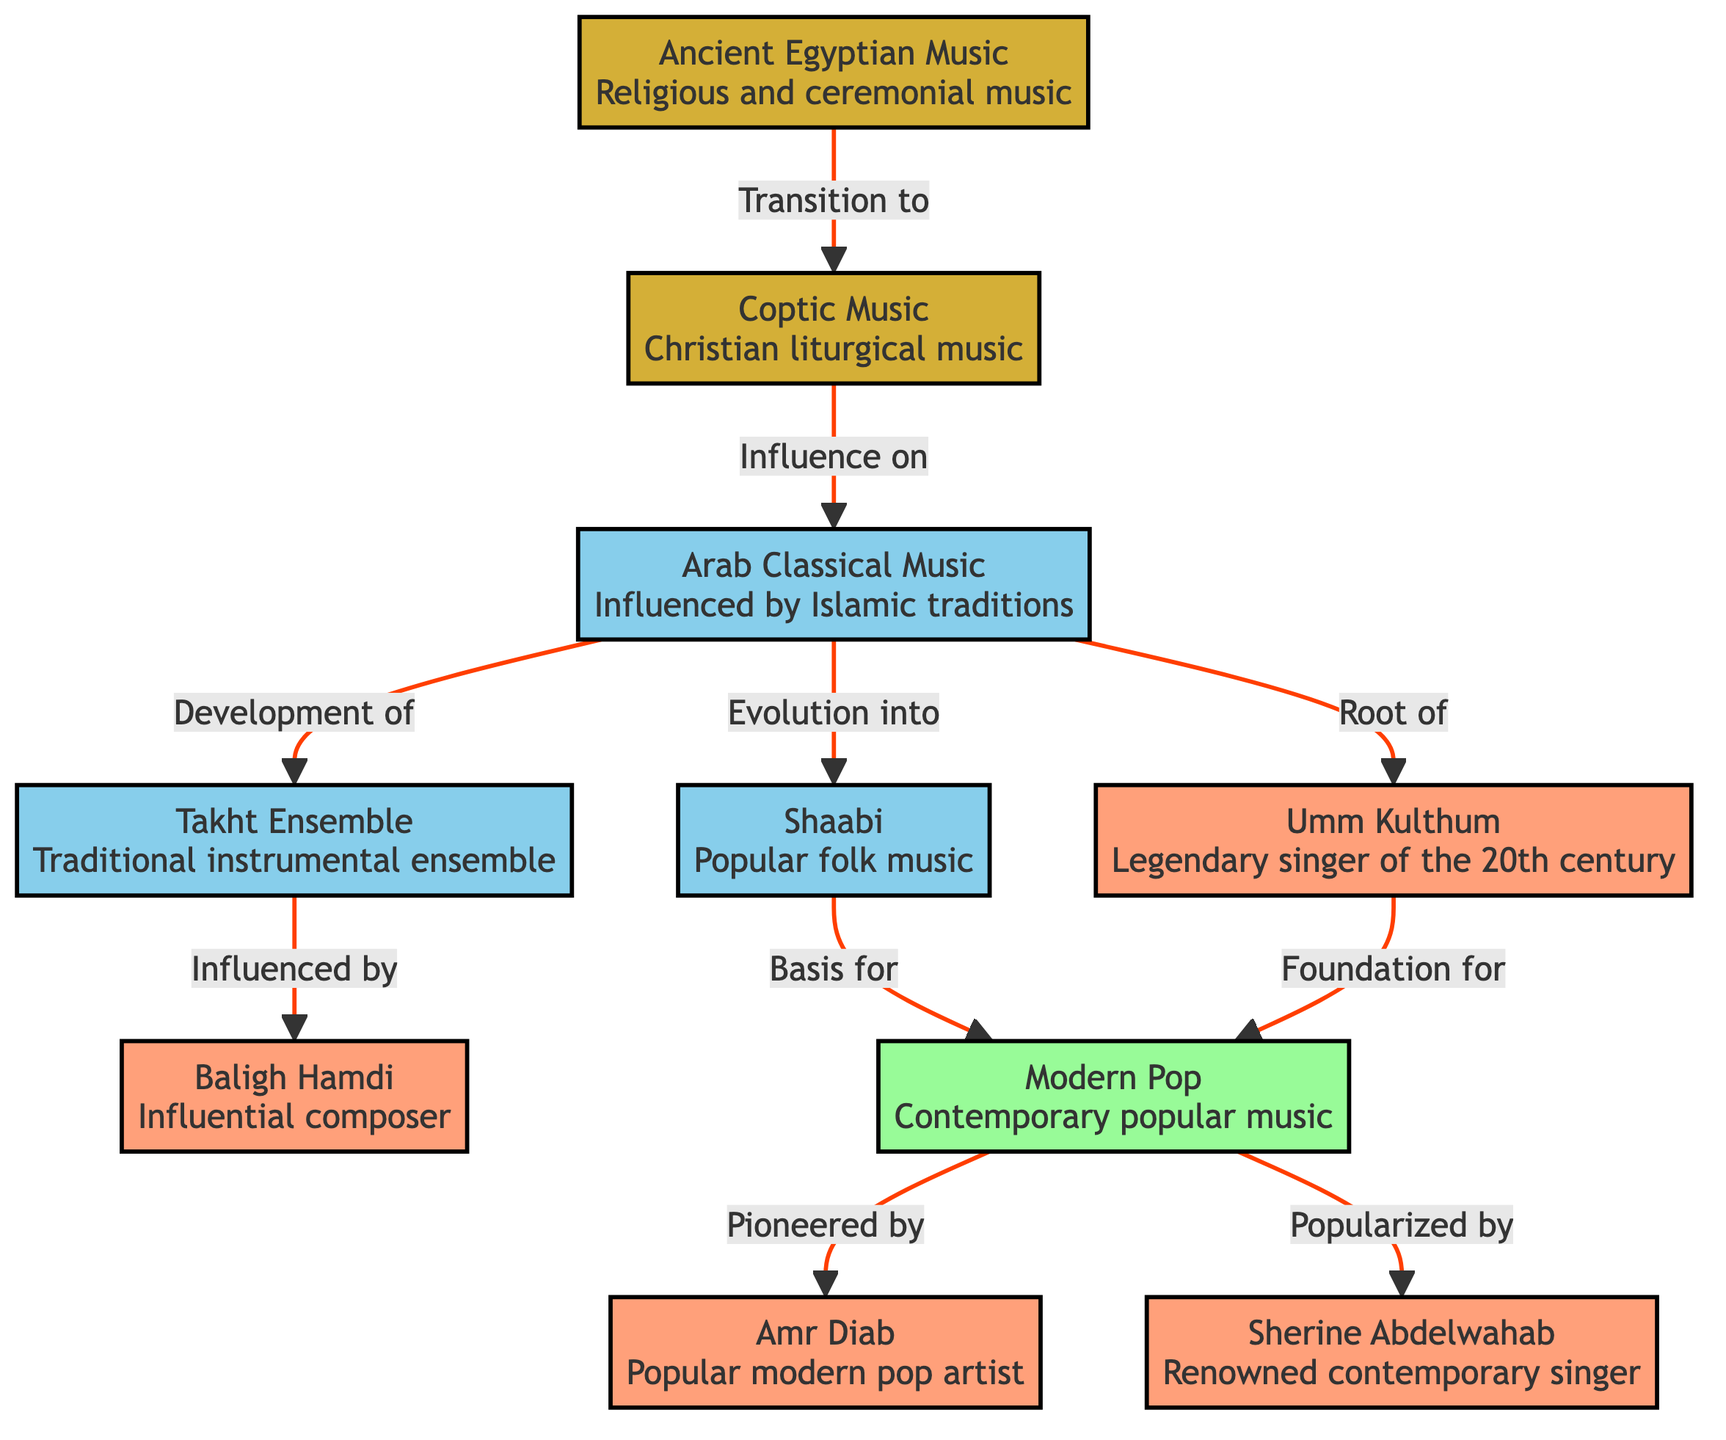What is the first genre of music shown in the diagram? The first node in the diagram is "Ancient Egyptian Music," indicating that it is the initial genre represented in the historical evolution of Egyptian music.
Answer: Ancient Egyptian Music How many artist nodes are present in the diagram? There are four nodes that are categorized as artists: Baligh Hamdi, Umm Kulthum, Amr Diab, and Sherine Abdelwahab. Therefore, by counting these nodes, we find that there are four artist nodes in total.
Answer: 4 What genre evolved into Shaabi music? The diagram indicates that the "Arab Classical Music" genre evolved into "Shaabi," establishing a direct connection between these two types of music.
Answer: Arab Classical Music Who is the legendary singer of the 20th century according to the diagram? The diagram specifies "Umm Kulthum" as the legendary singer of the 20th century, as illustrated in the corresponding node.
Answer: Umm Kulthum Which genre is popularized by Sherine Abdelwahab? The diagram shows that "Modern Pop" music is popularized by Sherine Abdelwahab, establishing her role in the contemporary music scene.
Answer: Modern Pop What transition occurs from Ancient Egyptian Music to Coptic Music? The diagram illustrates that there is a direct transition from "Ancient Egyptian Music" to "Coptic Music," designating Coptic music as an influence in ecclesiastical traditions emerging from ancient practices.
Answer: Transition to How is Baligh Hamdi related to the Takht Ensemble? The diagram explicitly states that the "Takht Ensemble" is influenced by Baligh Hamdi, indicating that his compositions or arrangements had a notable impact on this traditional instrumental group.
Answer: Influenced by Which genre serves as a foundation for Modern Pop? Both "Shaabi" music and the contributions by Umm Kulthum lay the foundation for "Modern Pop," as identified in the diagram's flow between these genres.
Answer: Shaabi How many transitions or influences does Arab Classical Music have? The diagram shows three connections from "Arab Classical Music": it evolves into "Shaabi," contributes to the development of "Takht Ensemble," and serves as a root for "Umm Kulthum." This sums it up to three transitions or influences.
Answer: 3 